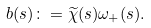Convert formula to latex. <formula><loc_0><loc_0><loc_500><loc_500>b ( s ) \colon = \widetilde { \chi } ( s ) \omega _ { + } ( s ) .</formula> 